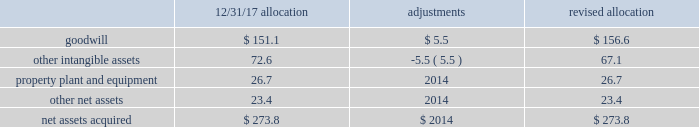Sacramento container acquisition in october 2017 , pca acquired substantially all of the assets of sacramento container corporation , and 100% ( 100 % ) of the membership interests of northern sheets , llc and central california sheets , llc ( collectively referred to as 201csacramento container 201d ) for a purchase price of $ 274 million , including working capital adjustments .
Funding for the acquisition came from available cash on hand .
Assets acquired include full-line corrugated products and sheet feeder operations in both mcclellan , california and kingsburg , california .
Sacramento container provides packaging solutions to customers serving portions of california 2019s strong agricultural market .
Sacramento container 2019s financial results are included in the packaging segment from the date of acquisition .
The company accounted for the sacramento container acquisition using the acquisition method of accounting in accordance with asc 805 , business combinations .
The total purchase price has been allocated to tangible and intangible assets acquired and liabilities assumed based on respective fair values , as follows ( dollars in millions ) : .
During the second quarter ended june 30 , 2018 , we made a $ 5.5 million net adjustment based on the final valuation of the intangible assets .
We recorded the adjustment as a decrease to other intangible assets with an offset to goodwill .
Goodwill is calculated as the excess of the purchase price over the fair value of the net assets acquired .
Among the factors that contributed to the recognition of goodwill were sacramento container 2019s commitment to continuous improvement and regional synergies , as well as the expected increases in pca 2019s containerboard integration levels .
Goodwill is deductible for tax purposes .
Other intangible assets , primarily customer relationships , were assigned an estimated weighted average useful life of 9.6 years .
Property , plant and equipment were assigned estimated useful lives ranging from one to 13 years. .
What percentage of the revised allocation of net assets acquired is goodwill? 
Computations: (156.6 / 273.8)
Answer: 0.57195. 